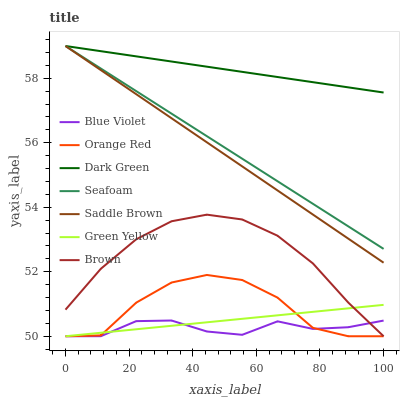Does Seafoam have the minimum area under the curve?
Answer yes or no. No. Does Seafoam have the maximum area under the curve?
Answer yes or no. No. Is Seafoam the smoothest?
Answer yes or no. No. Is Seafoam the roughest?
Answer yes or no. No. Does Seafoam have the lowest value?
Answer yes or no. No. Does Orange Red have the highest value?
Answer yes or no. No. Is Brown less than Seafoam?
Answer yes or no. Yes. Is Saddle Brown greater than Blue Violet?
Answer yes or no. Yes. Does Brown intersect Seafoam?
Answer yes or no. No. 